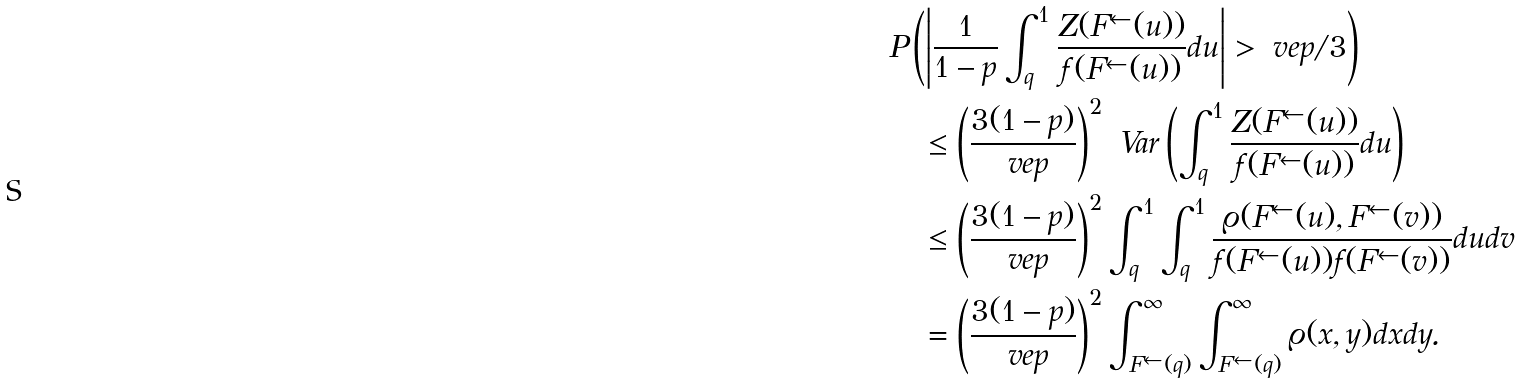<formula> <loc_0><loc_0><loc_500><loc_500>& P \left ( \left | \frac { 1 } { 1 - p } \int _ { q } ^ { 1 } \frac { Z ( F ^ { \leftarrow } ( u ) ) } { f ( F ^ { \leftarrow } ( u ) ) } d u \right | > \ v e p / 3 \right ) \\ & \quad \leq \left ( \frac { 3 ( 1 - p ) } { \ v e p } \right ) ^ { 2 } \ V a r \left ( \int _ { q } ^ { 1 } \frac { Z ( F ^ { \leftarrow } ( u ) ) } { f ( F ^ { \leftarrow } ( u ) ) } d u \right ) \\ & \quad \leq \left ( \frac { 3 ( 1 - p ) } { \ v e p } \right ) ^ { 2 } \int _ { q } ^ { 1 } \int _ { q } ^ { 1 } \frac { \varrho ( F ^ { \leftarrow } ( u ) , F ^ { \leftarrow } ( v ) ) } { f ( F ^ { \leftarrow } ( u ) ) f ( F ^ { \leftarrow } ( v ) ) } d u d v \\ & \quad = \left ( \frac { 3 ( 1 - p ) } { \ v e p } \right ) ^ { 2 } \int _ { F ^ { \leftarrow } ( q ) } ^ { \infty } \int _ { F ^ { \leftarrow } ( q ) } ^ { \infty } \varrho ( x , y ) d x d y .</formula> 